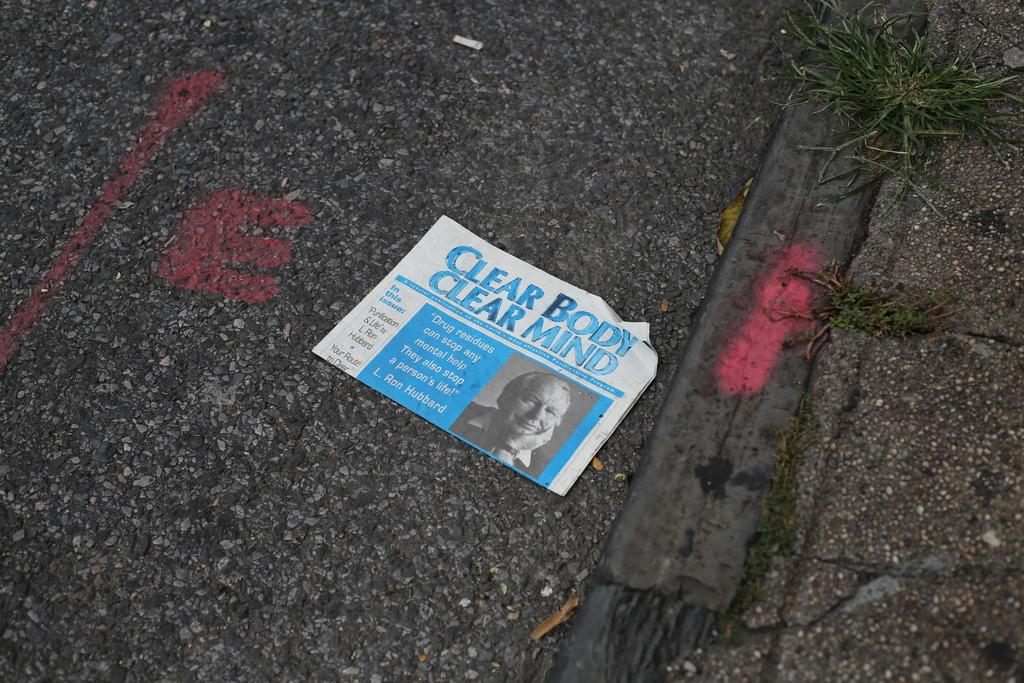What is written on the paper in the image? The provided facts do not specify the content of the text on the paper. What type of vegetation can be seen in the image? There is grass visible in the image. Can you see a family playing on the swing in the image? There is no swing or family present in the image; it only features a paper with text and grass. 